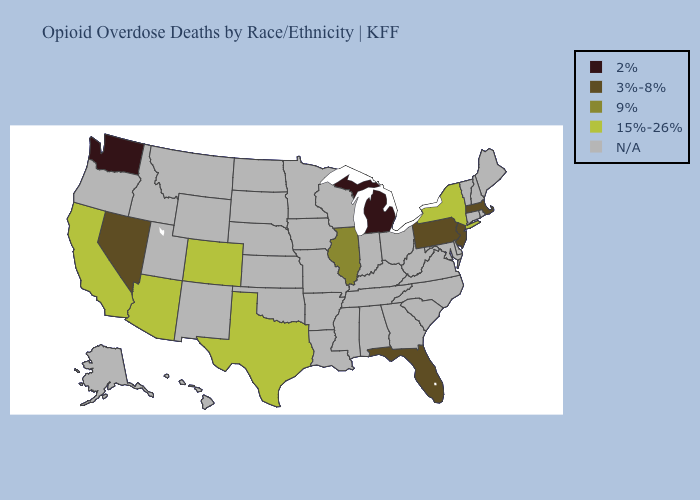Among the states that border New Jersey , which have the highest value?
Give a very brief answer. New York. Name the states that have a value in the range N/A?
Concise answer only. Alabama, Alaska, Arkansas, Connecticut, Delaware, Georgia, Hawaii, Idaho, Indiana, Iowa, Kansas, Kentucky, Louisiana, Maine, Maryland, Minnesota, Mississippi, Missouri, Montana, Nebraska, New Hampshire, New Mexico, North Carolina, North Dakota, Ohio, Oklahoma, Oregon, Rhode Island, South Carolina, South Dakota, Tennessee, Utah, Vermont, Virginia, West Virginia, Wisconsin, Wyoming. Name the states that have a value in the range 15%-26%?
Write a very short answer. Arizona, California, Colorado, New York, Texas. Among the states that border Kentucky , which have the highest value?
Answer briefly. Illinois. What is the highest value in the USA?
Quick response, please. 15%-26%. Is the legend a continuous bar?
Give a very brief answer. No. Does Michigan have the lowest value in the USA?
Give a very brief answer. Yes. What is the value of Hawaii?
Give a very brief answer. N/A. What is the value of Kansas?
Give a very brief answer. N/A. What is the lowest value in states that border Ohio?
Be succinct. 2%. Name the states that have a value in the range 15%-26%?
Short answer required. Arizona, California, Colorado, New York, Texas. What is the lowest value in the MidWest?
Answer briefly. 2%. Does Illinois have the highest value in the MidWest?
Short answer required. Yes. 